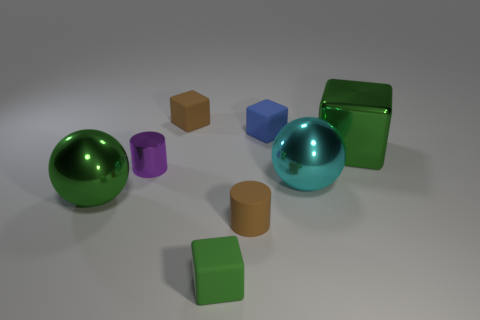Are any large brown cylinders visible?
Make the answer very short. No. What is the green object that is on the right side of the purple metal thing and in front of the large cyan metal thing made of?
Your response must be concise. Rubber. Is the number of tiny brown things that are in front of the brown cube greater than the number of big cyan objects that are in front of the shiny cylinder?
Your answer should be very brief. No. Are there any blue metallic spheres of the same size as the green sphere?
Your response must be concise. No. What size is the rubber cube in front of the metallic ball to the left of the tiny matte thing right of the small brown rubber cylinder?
Your answer should be very brief. Small. What color is the small rubber cylinder?
Your response must be concise. Brown. Is the number of metallic spheres on the right side of the blue matte block greater than the number of yellow blocks?
Your answer should be compact. Yes. What number of tiny brown matte blocks are on the right side of the cyan metallic sphere?
Your response must be concise. 0. The small rubber object that is the same color as the rubber cylinder is what shape?
Your answer should be very brief. Cube. Is there a blue block in front of the green block that is on the right side of the matte cube that is in front of the tiny blue object?
Ensure brevity in your answer.  No. 